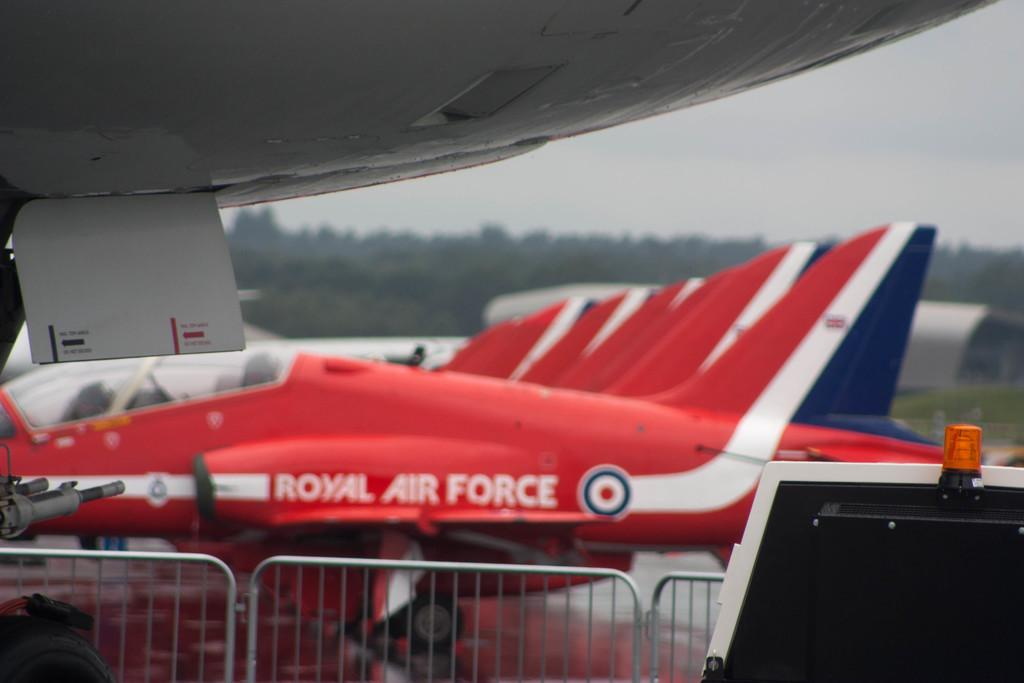<image>
Describe the image concisely. Royal Air France jets are lined up and photographed from the side. 